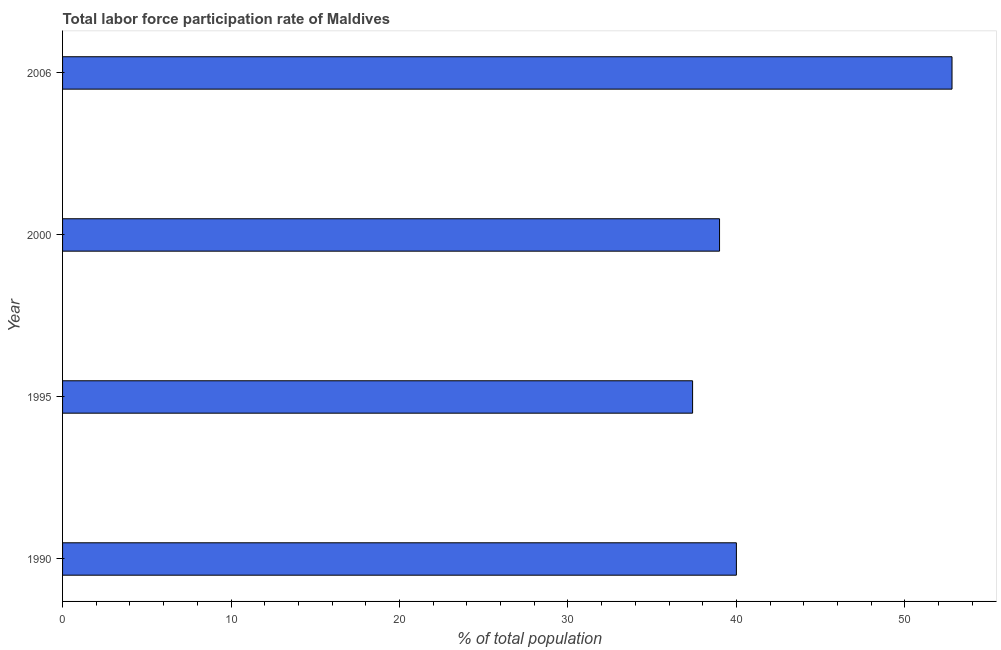What is the title of the graph?
Offer a terse response. Total labor force participation rate of Maldives. What is the label or title of the X-axis?
Ensure brevity in your answer.  % of total population. What is the total labor force participation rate in 2006?
Your answer should be very brief. 52.8. Across all years, what is the maximum total labor force participation rate?
Provide a succinct answer. 52.8. Across all years, what is the minimum total labor force participation rate?
Keep it short and to the point. 37.4. In which year was the total labor force participation rate minimum?
Give a very brief answer. 1995. What is the sum of the total labor force participation rate?
Ensure brevity in your answer.  169.2. What is the difference between the total labor force participation rate in 1995 and 2000?
Offer a very short reply. -1.6. What is the average total labor force participation rate per year?
Your answer should be compact. 42.3. What is the median total labor force participation rate?
Your response must be concise. 39.5. Do a majority of the years between 2006 and 1995 (inclusive) have total labor force participation rate greater than 2 %?
Your answer should be compact. Yes. What is the ratio of the total labor force participation rate in 1995 to that in 2006?
Make the answer very short. 0.71. Is the difference between the total labor force participation rate in 2000 and 2006 greater than the difference between any two years?
Keep it short and to the point. No. What is the difference between the highest and the second highest total labor force participation rate?
Offer a terse response. 12.8. What is the difference between the highest and the lowest total labor force participation rate?
Your answer should be very brief. 15.4. In how many years, is the total labor force participation rate greater than the average total labor force participation rate taken over all years?
Offer a terse response. 1. How many years are there in the graph?
Keep it short and to the point. 4. Are the values on the major ticks of X-axis written in scientific E-notation?
Provide a short and direct response. No. What is the % of total population in 1995?
Give a very brief answer. 37.4. What is the % of total population in 2000?
Your answer should be very brief. 39. What is the % of total population of 2006?
Your response must be concise. 52.8. What is the difference between the % of total population in 1990 and 1995?
Your answer should be very brief. 2.6. What is the difference between the % of total population in 1990 and 2000?
Your response must be concise. 1. What is the difference between the % of total population in 1995 and 2006?
Give a very brief answer. -15.4. What is the difference between the % of total population in 2000 and 2006?
Provide a succinct answer. -13.8. What is the ratio of the % of total population in 1990 to that in 1995?
Provide a succinct answer. 1.07. What is the ratio of the % of total population in 1990 to that in 2006?
Make the answer very short. 0.76. What is the ratio of the % of total population in 1995 to that in 2006?
Offer a very short reply. 0.71. What is the ratio of the % of total population in 2000 to that in 2006?
Offer a terse response. 0.74. 